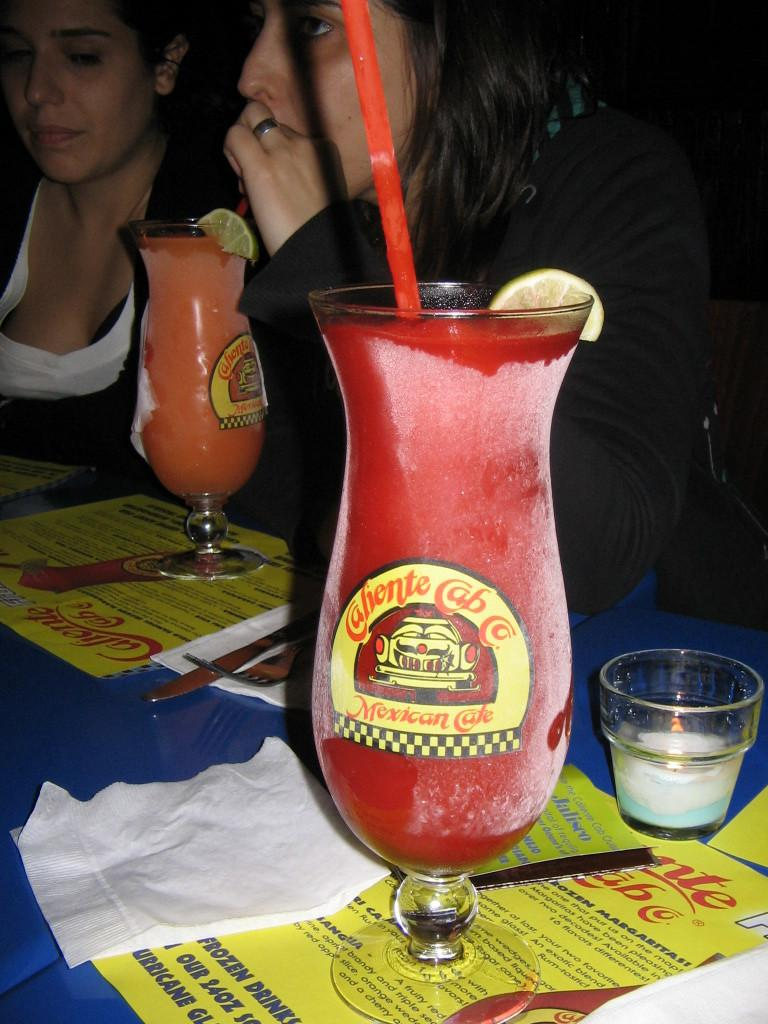What is located in the foreground of the picture? There is a table in the foreground of the picture. What items can be found on the table? On the table, there are pamphlets, glasses, juice, a lemon, straws, and tissues. Are there any other objects on the table? Yes, there are other objects on the table. How many women are visible in the image? There are two women visible at the top of the image. What type of circle can be seen in the image? There is no circle present in the image. What season is depicted in the image? The provided facts do not mention any seasonal details, so it cannot be determined from the image. 